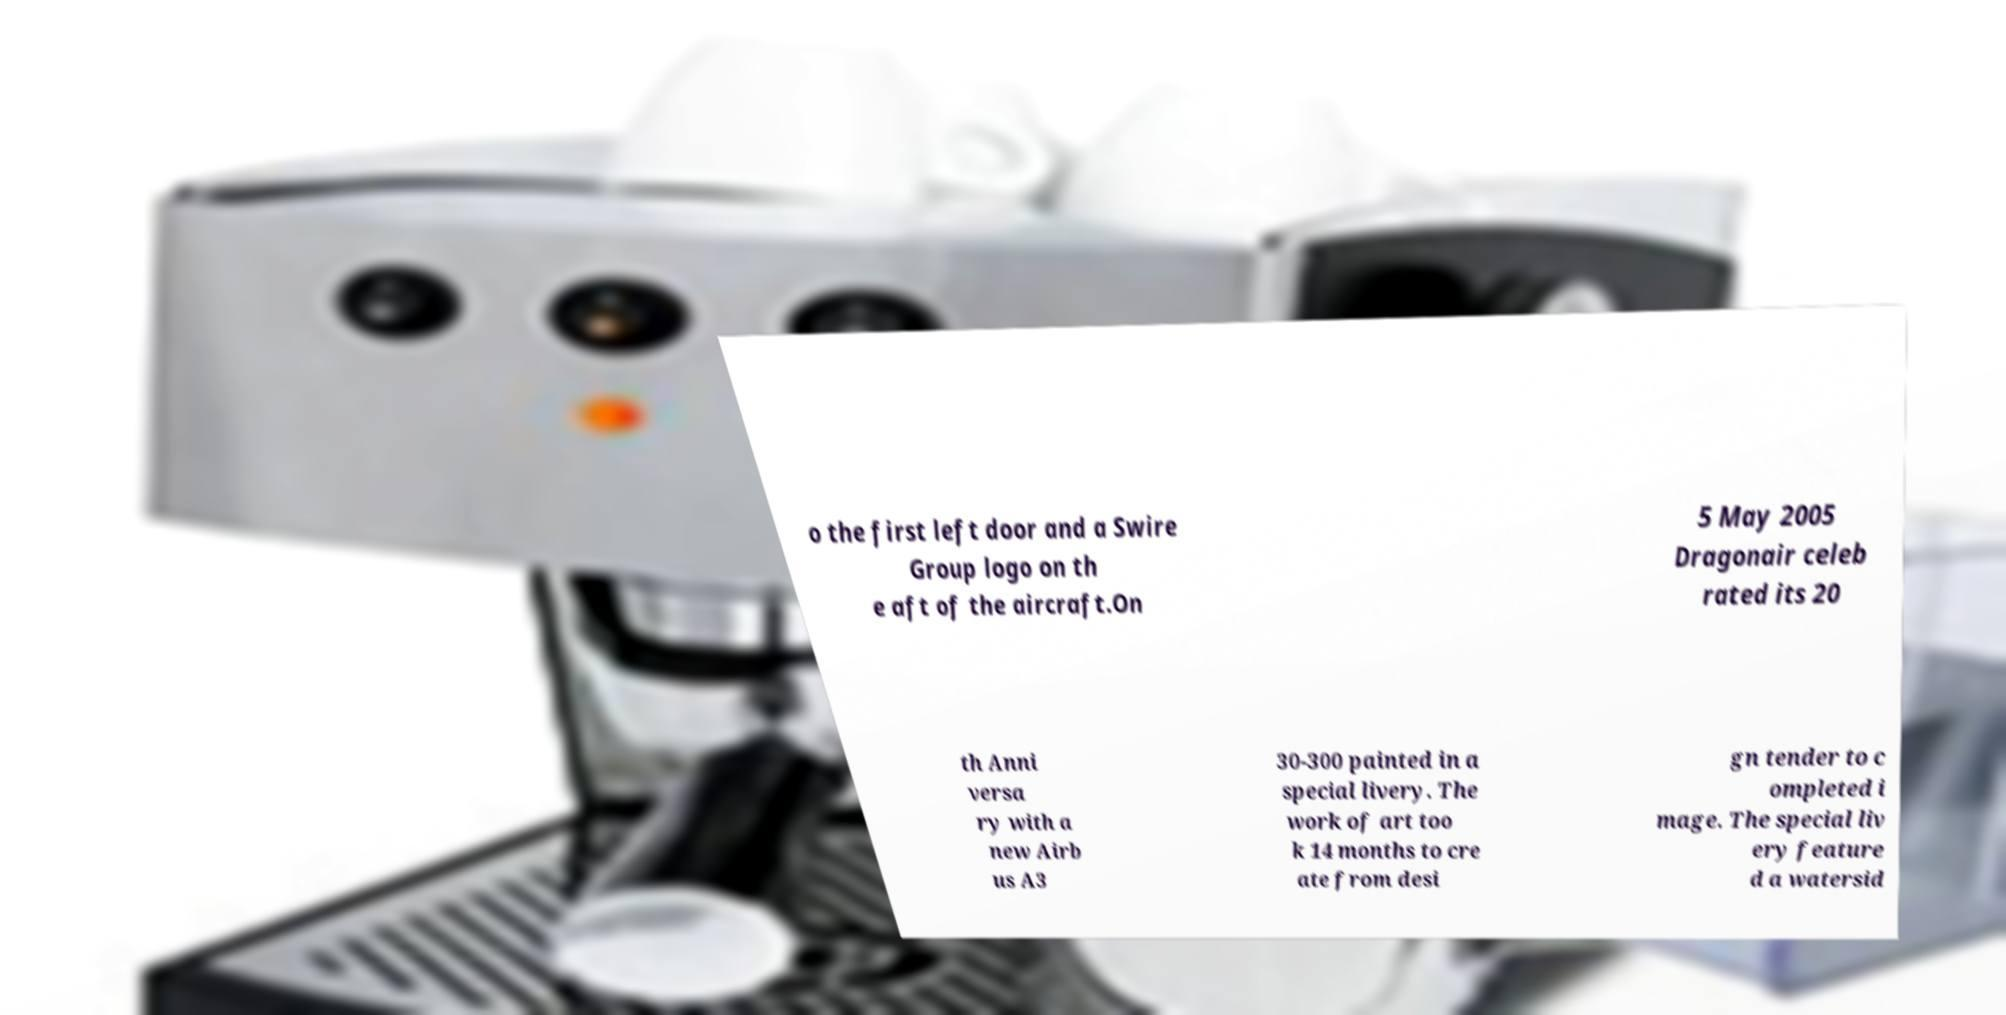Can you read and provide the text displayed in the image?This photo seems to have some interesting text. Can you extract and type it out for me? o the first left door and a Swire Group logo on th e aft of the aircraft.On 5 May 2005 Dragonair celeb rated its 20 th Anni versa ry with a new Airb us A3 30-300 painted in a special livery. The work of art too k 14 months to cre ate from desi gn tender to c ompleted i mage. The special liv ery feature d a watersid 